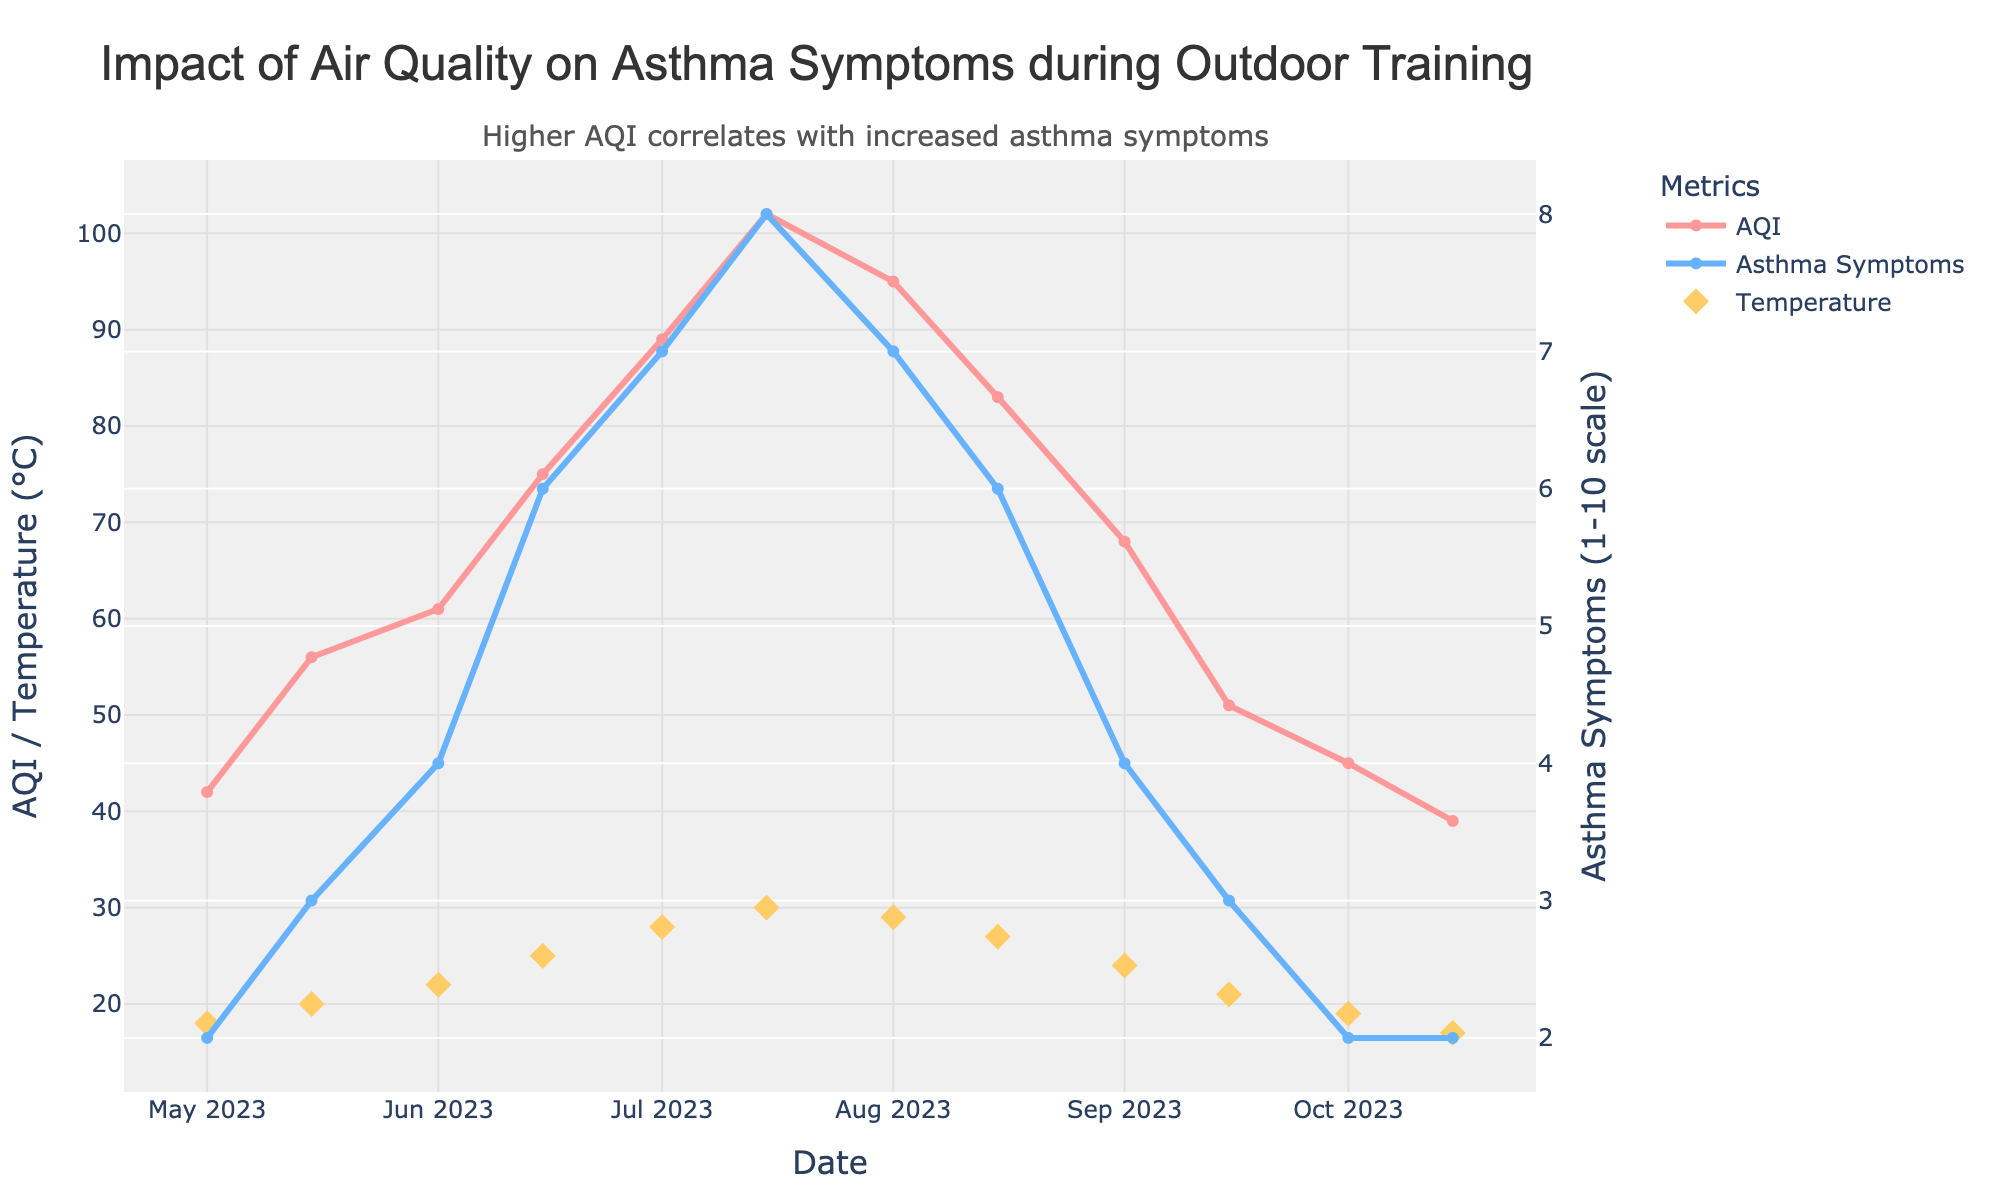What's the peak Air Quality Index (AQI) shown in the chart? Look for the highest point on the AQI line in the chart. It peaks at the maximum value.
Answer: 102 What was the asthma symptom report level when AQI was at its peak? Find the date when AQI peaked and then look at the corresponding asthma symptom report level on the same date. AQI peaked on 2023-07-15, where asthma symptoms were at level 8.
Answer: 8 Did the temperature increase or decrease when AQI was at its highest? On July 15, the AQI was highest. Check the marker on the temperature line on the same date. It shows 30°C, indicating an increase compared to previous dates.
Answer: Increase How does the asthma symptom level on 2023-05-01 compare with the level on 2023-07-01? Check the asthma symptoms levels on May 1 and July 1, then compare them. May 1 shows 2, and July 1 shows 7, indicating an increase.
Answer: Increased What is the average training duration in minutes over the entire period? Sum all the training durations and divide by the number of dates. Calculation: (60+45+30+40+35+25+30+45+50+60+55+65)/12 = 45
Answer: 45 On which date did the asthma symptom level first reach 6? Find the first instance where the asthma symptom line reaches 6. This occurs on June 15.
Answer: 2023-06-15 Is there a general trend between AQI and asthma symptoms reported? Observe both the AQI and asthma symptoms lines. As the AQI increases, the asthma symptoms generally increase too, indicating a positive correlation.
Answer: Yes Which was generally higher throughout the period, AQI or Temperature? Compare the AQI and temperature values across the dates. Generally, AQI values are higher.
Answer: AQI What's the difference in AQI and asthma symptoms reported on 2023-08-01? Find values for AQI (95) and asthma symptoms (7) on August 1 and subtract: 95 - 7 = 88.
Answer: 88 